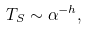<formula> <loc_0><loc_0><loc_500><loc_500>T _ { S } \sim \alpha ^ { - h } ,</formula> 